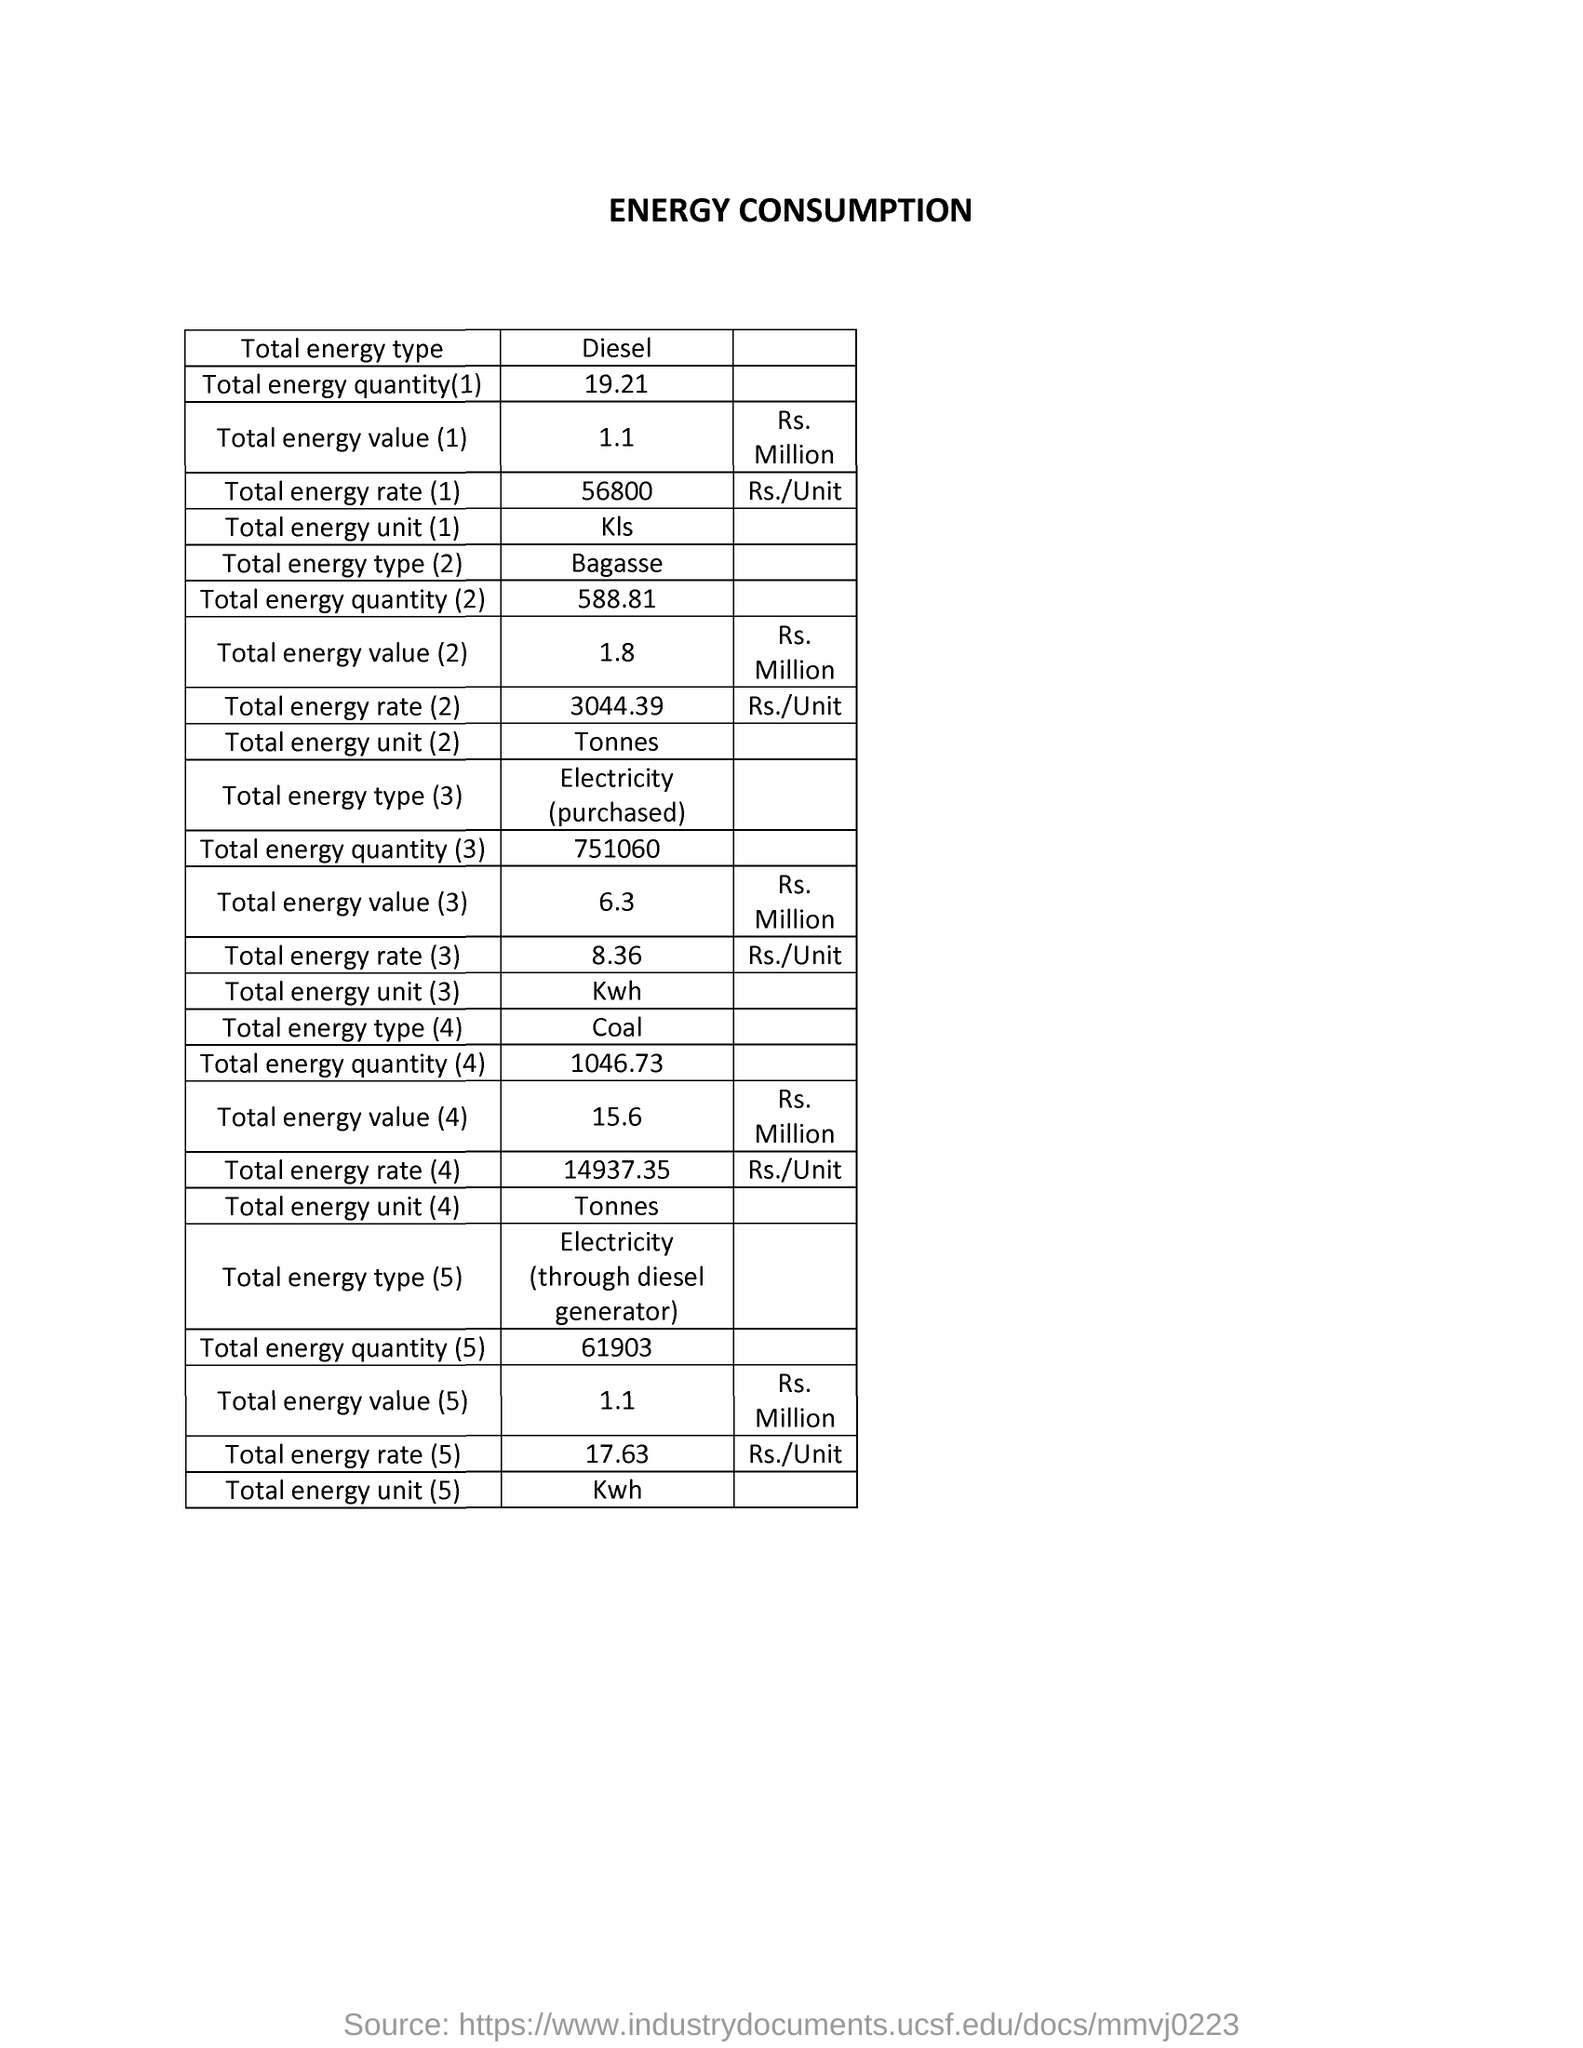Draw attention to some important aspects in this diagram. The total energy rate for energy type coal is 14,937.35 Indian Rupees per unit. The total energy unit of Bagasse is tonnes. The total energy value for the energy type diesel is 1.1 Rs. Million. The title of the document is Energy Consumption. The total energy rate for diesel is 56,800. 